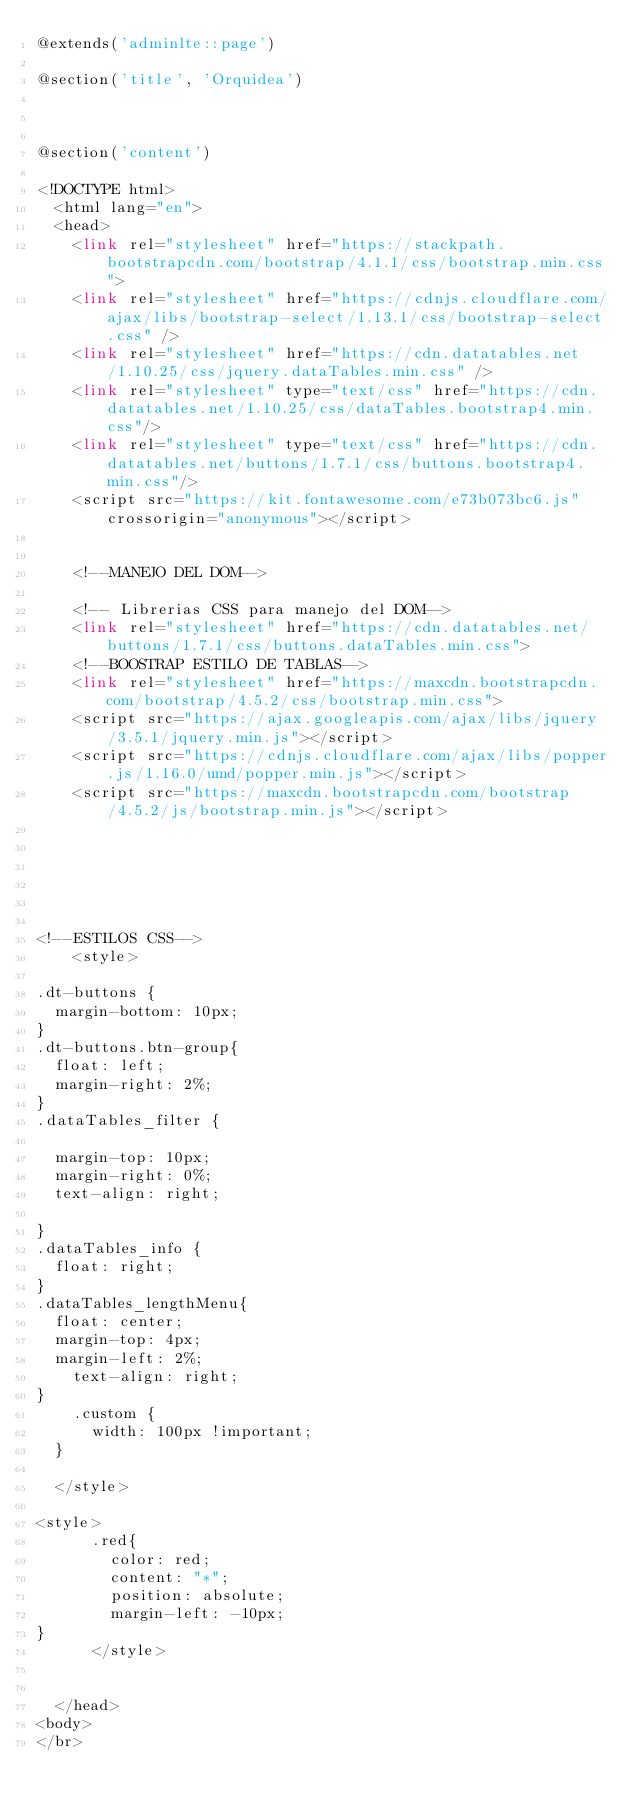<code> <loc_0><loc_0><loc_500><loc_500><_PHP_>@extends('adminlte::page')

@section('title', 'Orquidea')



@section('content')

<!DOCTYPE html>
  <html lang="en">
  <head>
    <link rel="stylesheet" href="https://stackpath.bootstrapcdn.com/bootstrap/4.1.1/css/bootstrap.min.css">
    <link rel="stylesheet" href="https://cdnjs.cloudflare.com/ajax/libs/bootstrap-select/1.13.1/css/bootstrap-select.css" />
    <link rel="stylesheet" href="https://cdn.datatables.net/1.10.25/css/jquery.dataTables.min.css" />
    <link rel="stylesheet" type="text/css" href="https://cdn.datatables.net/1.10.25/css/dataTables.bootstrap4.min.css"/>
    <link rel="stylesheet" type="text/css" href="https://cdn.datatables.net/buttons/1.7.1/css/buttons.bootstrap4.min.css"/>   
    <script src="https://kit.fontawesome.com/e73b073bc6.js" crossorigin="anonymous"></script>


    <!--MANEJO DEL DOM-->
    
    <!-- Librerias CSS para manejo del DOM-->
    <link rel="stylesheet" href="https://cdn.datatables.net/buttons/1.7.1/css/buttons.dataTables.min.css">
    <!--BOOSTRAP ESTILO DE TABLAS-->
    <link rel="stylesheet" href="https://maxcdn.bootstrapcdn.com/bootstrap/4.5.2/css/bootstrap.min.css">
    <script src="https://ajax.googleapis.com/ajax/libs/jquery/3.5.1/jquery.min.js"></script>
    <script src="https://cdnjs.cloudflare.com/ajax/libs/popper.js/1.16.0/umd/popper.min.js"></script>
    <script src="https://maxcdn.bootstrapcdn.com/bootstrap/4.5.2/js/bootstrap.min.js"></script>






<!--ESTILOS CSS-->
    <style>

.dt-buttons {
	margin-bottom: 10px;
}
.dt-buttons.btn-group{
	float: left;
	margin-right: 2%;
}
.dataTables_filter {
	
	margin-top: 10px;
	margin-right: 0%;
	text-align: right;
    
}
.dataTables_info {
	float: right;
}
.dataTables_lengthMenu{
	float: center;
	margin-top: 4px;
	margin-left: 2%;
    text-align: right;
}
    .custom {
      width: 100px !important;
  }

  </style>

<style>
      .red{
        color: red;
        content: "*";
        position: absolute;
        margin-left: -10px;
}
      </style>


  </head>
<body>  
</br></code> 